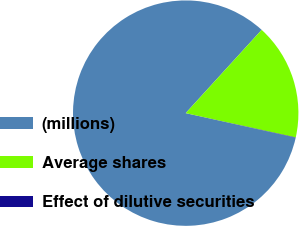Convert chart to OTSL. <chart><loc_0><loc_0><loc_500><loc_500><pie_chart><fcel>(millions)<fcel>Average shares<fcel>Effect of dilutive securities<nl><fcel>83.27%<fcel>16.69%<fcel>0.05%<nl></chart> 